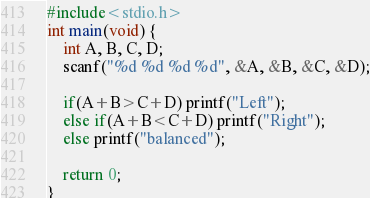<code> <loc_0><loc_0><loc_500><loc_500><_C_>#include<stdio.h>
int main(void) {
	int A, B, C, D;
	scanf("%d %d %d %d", &A, &B, &C, &D);

	if(A+B>C+D) printf("Left");
	else if(A+B<C+D) printf("Right");
	else printf("balanced");

	return 0;
}</code> 